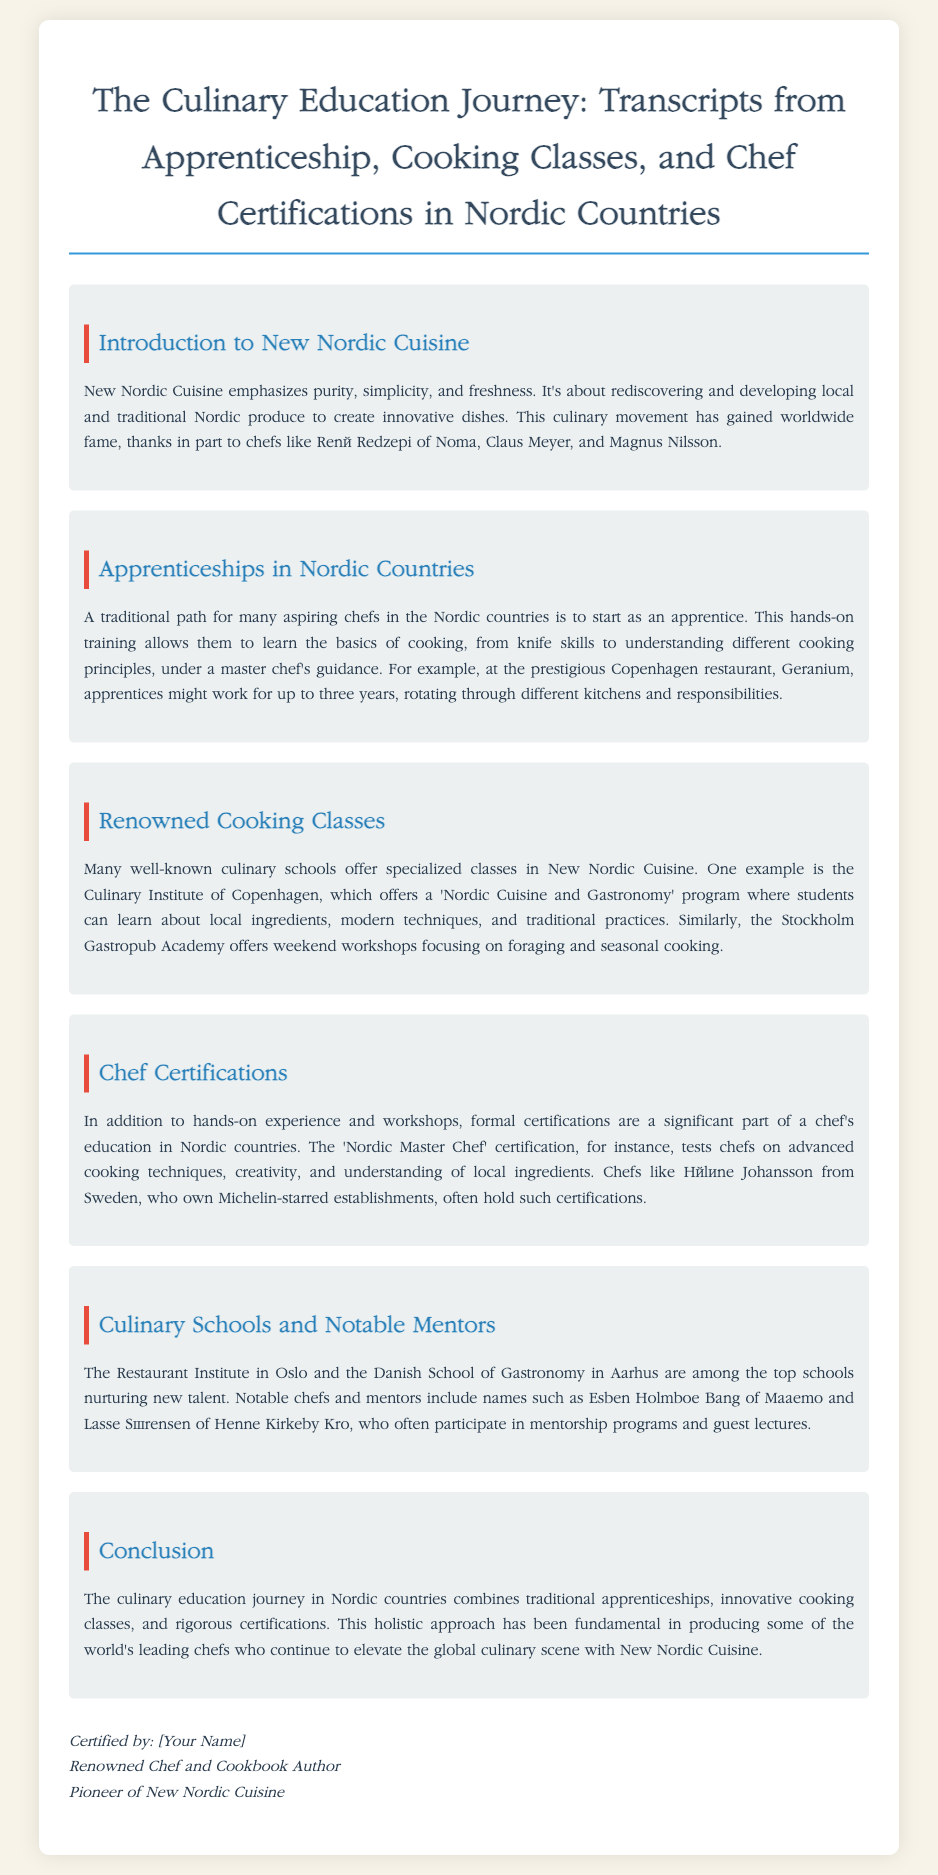What is New Nordic Cuisine focused on? New Nordic Cuisine emphasizes purity, simplicity, and freshness as highlighted in the introduction.
Answer: purity, simplicity, and freshness How long can apprentices work at Geranium? The document states that apprentices at Geranium might work for up to three years.
Answer: three years What program does the Culinary Institute of Copenhagen offer? A 'Nordic Cuisine and Gastronomy' program is mentioned in the document under renowned cooking classes.
Answer: Nordic Cuisine and Gastronomy What is the name of the certification that tests advanced cooking techniques? The 'Nordic Master Chef' certification is specified for testing advanced cooking techniques in the document.
Answer: Nordic Master Chef Which school is located in Oslo? The Restaurant Institute is mentioned as being located in Oslo and nurturing new talent.
Answer: Restaurant Institute Who is a notable chef from Sweden that holds certifications? Hélène Johansson is recognized in the document as a notable chef from Sweden with certifications.
Answer: Hélène Johansson What is the primary learning method emphasized in apprenticeships? The primary learning method for aspiring chefs in the Nordic countries is hands-on training.
Answer: hands-on training What aspect of New Nordic Cuisine has gained worldwide fame? The movement's fame is attributed to chefs like René Redzepi, Claus Meyer, and Magnus Nilsson as stated in the introduction.
Answer: chefs like René Redzepi, Claus Meyer, and Magnus Nilsson What kind of cooking does the Stockholm Gastropub Academy focus on? The Stockholm Gastropub Academy offers workshops focusing on foraging and seasonal cooking.
Answer: foraging and seasonal cooking 